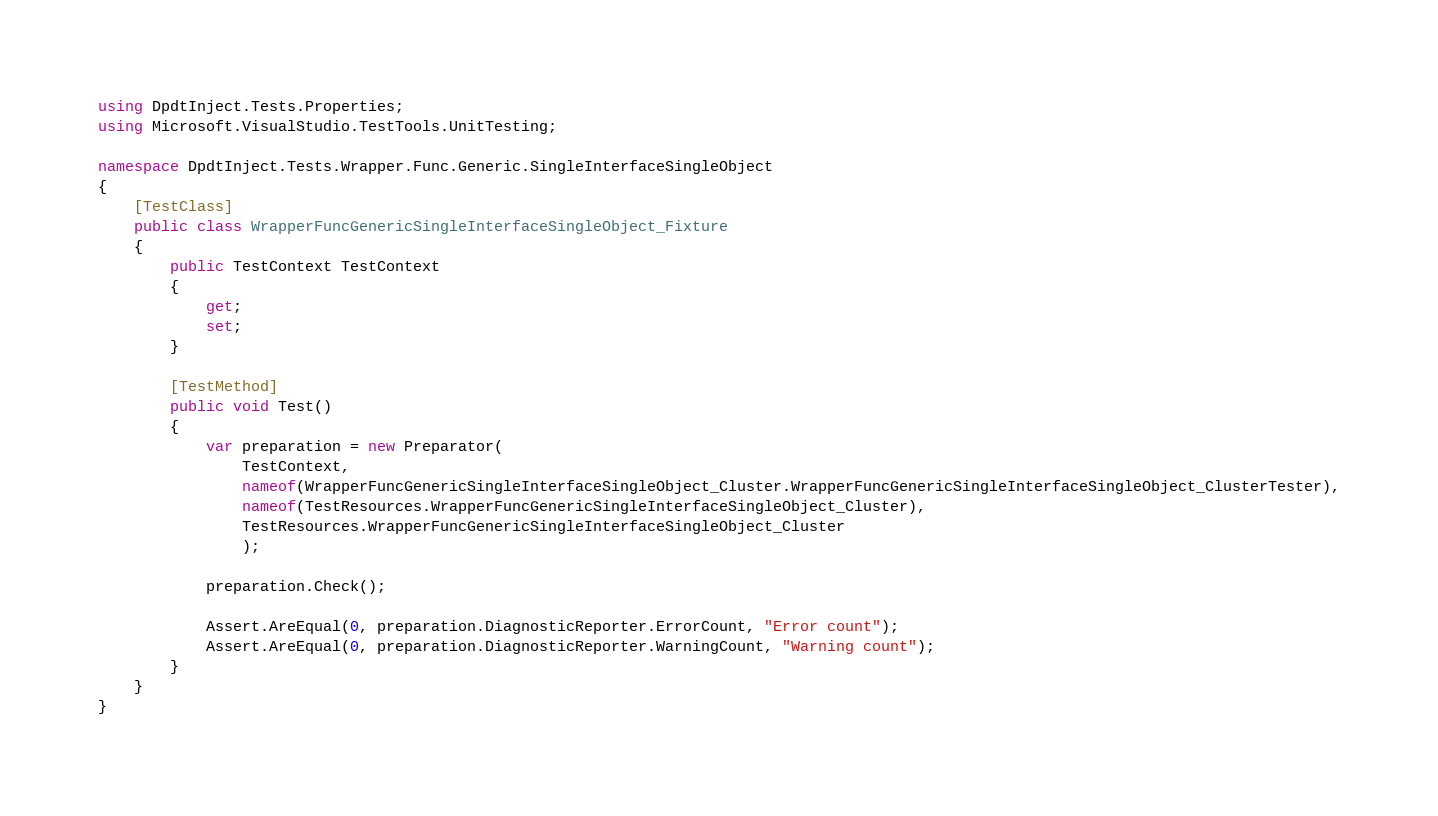<code> <loc_0><loc_0><loc_500><loc_500><_C#_>using DpdtInject.Tests.Properties;
using Microsoft.VisualStudio.TestTools.UnitTesting;

namespace DpdtInject.Tests.Wrapper.Func.Generic.SingleInterfaceSingleObject
{
    [TestClass]
    public class WrapperFuncGenericSingleInterfaceSingleObject_Fixture
    {
        public TestContext TestContext
        {
            get;
            set;
        }

        [TestMethod]
        public void Test()
        {
            var preparation = new Preparator(
                TestContext,
                nameof(WrapperFuncGenericSingleInterfaceSingleObject_Cluster.WrapperFuncGenericSingleInterfaceSingleObject_ClusterTester),
                nameof(TestResources.WrapperFuncGenericSingleInterfaceSingleObject_Cluster),
                TestResources.WrapperFuncGenericSingleInterfaceSingleObject_Cluster
                );

            preparation.Check();

            Assert.AreEqual(0, preparation.DiagnosticReporter.ErrorCount, "Error count");
            Assert.AreEqual(0, preparation.DiagnosticReporter.WarningCount, "Warning count");
        }
    }
}
</code> 